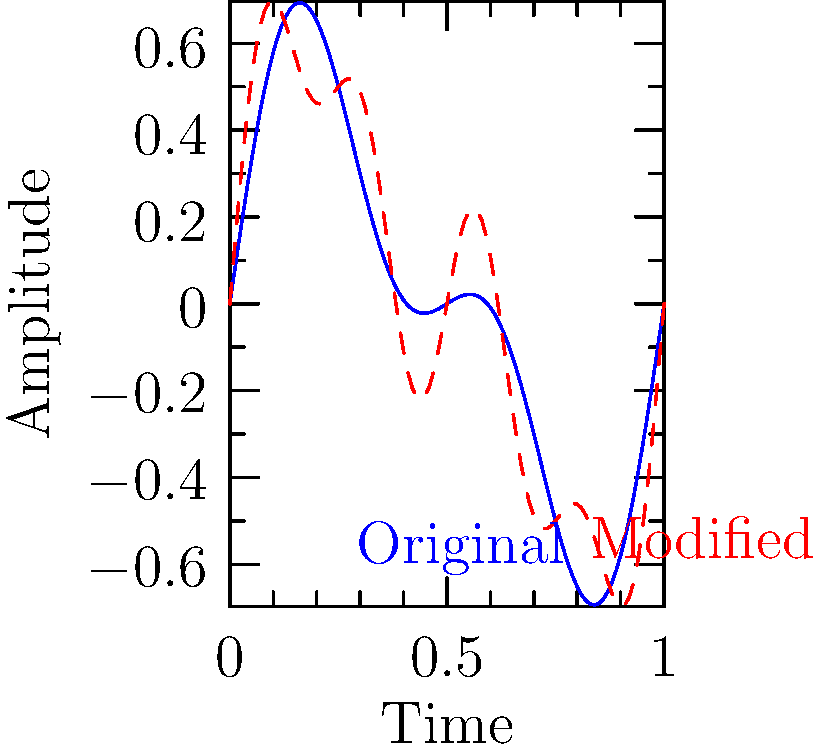In the context of digital audio manipulation, which topological operation is represented by the transformation from the blue (original) waveform to the red (modified) waveform in the graph? To determine the topological operation represented by the transformation, let's analyze the changes step-by-step:

1. Observe the original waveform (blue): It appears to be a complex wave, likely composed of multiple sine waves.

2. Compare the modified waveform (red) to the original:
   a. The overall shape and amplitude of the wave are preserved.
   b. The modified wave follows the general contour of the original wave.
   c. The modified wave has additional "ripples" or oscillations superimposed on the original wave.

3. These characteristics suggest that a high-frequency component has been added to the original waveform.

4. In topological terms, this operation maintains the fundamental structure (homotopy) of the original waveform while introducing additional local variations.

5. In audio processing, this type of transformation is typically achieved by adding a new frequency component to the existing signal.

6. The mathematical operation that represents this transformation is addition of a new sinusoidal component:

   $f_{modified}(x) = f_{original}(x) + A \cdot \sin(2\pi fx)$

   Where $A$ is the amplitude and $f$ is the frequency of the added component.

7. In topology and digital signal processing, this operation is known as "superposition" or "signal addition."

Therefore, the topological operation represented by this transformation is superposition, which preserves the original signal's structure while adding new frequency content.
Answer: Superposition 